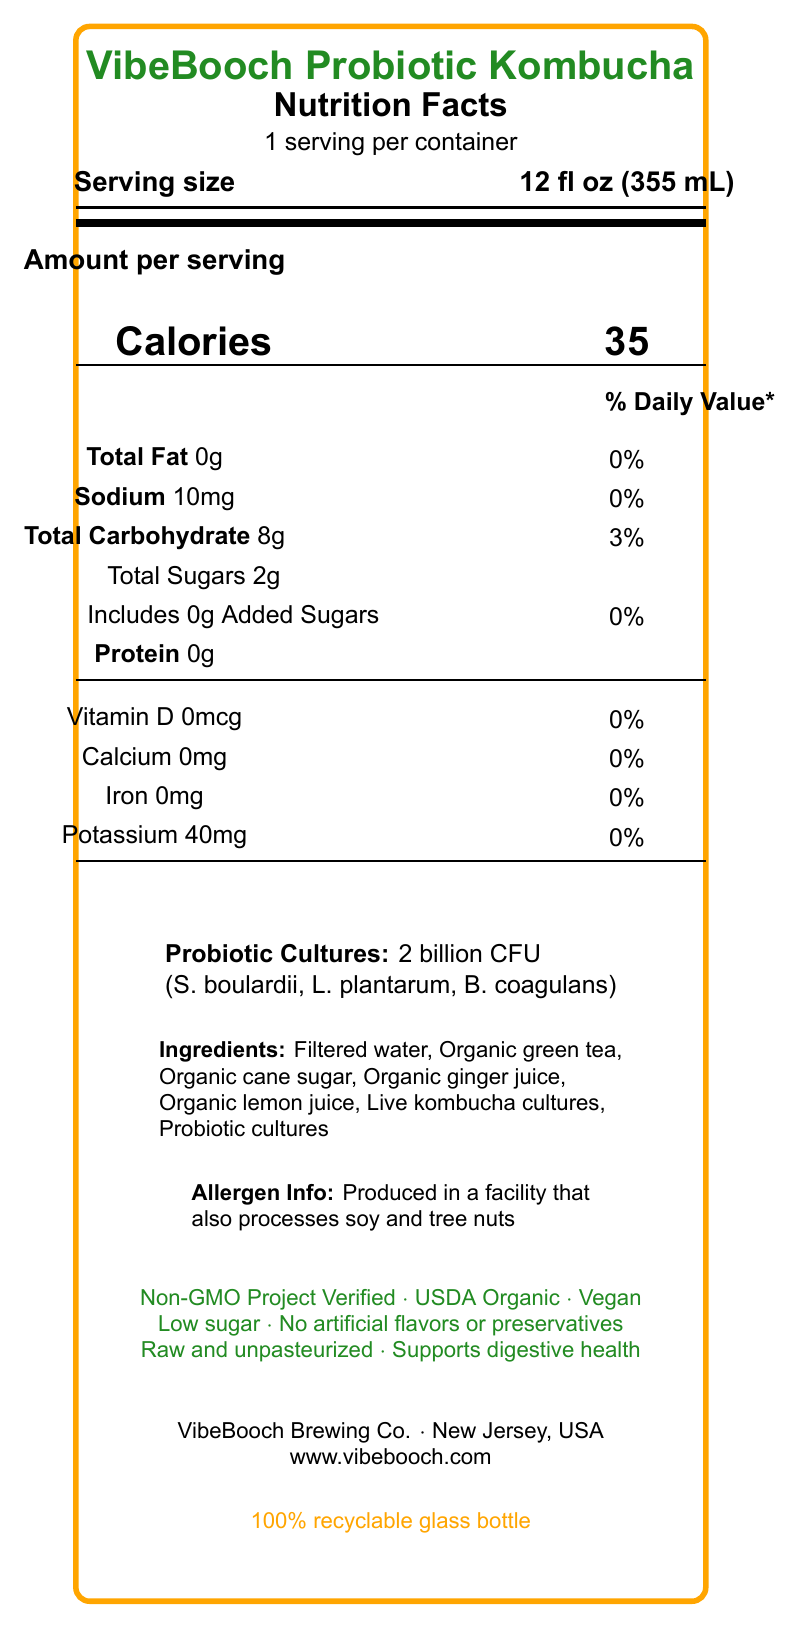what is the serving size of VibeBooch Probiotic Kombucha? The serving size is stated next to the label "Serving size" on the Nutrition Facts label.
Answer: 12 fl oz (355 mL) how many calories are in one serving of VibeBooch Probiotic Kombucha? The calorie content per serving is prominently displayed as "Calories 35" under the "Amount per serving" section.
Answer: 35 What is the total sugar content per serving? The total sugar content is listed under the "Total Sugars" section of the Nutrition Facts label.
Answer: 2g What is the amount of probiotic cultures in VibeBooch Probiotic Kombucha? The amount of probiotic cultures is listed under "Probiotic Cultures" with the details "2 billion CFU".
Answer: 2 billion CFU List the probiotic strains included in VibeBooch Probiotic Kombucha. The specific strains of probiotic cultures are listed in parentheses after "Probiotic Cultures".
Answer: Saccharomyces boulardii, Lactobacillus plantarum, Bacillus coagulans does VibeBooch Probiotic Kombucha contain added sugars? The label indicates "Includes 0g Added Sugars," meaning there are no added sugars in the drink.
Answer: No how much sodium is in one serving of VibeBooch Probiotic Kombucha? The sodium content is listed under "Sodium" in the Nutrition Facts label.
Answer: 10mg By how much can one serving of VibeBooch Probiotic Kombucha contribute to your daily carbohydrate intake? The % Daily Value for total carbohydrates in one serving is indicated as 3%.
Answer: 3% What certifications does VibeBooch hold? The certifications are listed towards the bottom of the document under the "Non-GMO Project Verified," "USDA Organic," and "Vegan" labels.
Answer: Non-GMO Project Verified, USDA Organic, Vegan In which type of packaging is VibeBooch Probiotic Kombucha sold? This information is listed at the bottom of the label, mentioning "100% recyclable glass bottle".
Answer: 100% recyclable glass bottle Does VibeBooch Probiotic Kombucha contain any artificial flavors or preservatives? One of the additional claims explicitly states "No artificial flavors or preservatives".
Answer: No Where is VibeBooch Probiotic Kombucha manufactured? The location of the manufacturer is listed towards the bottom of the label.
Answer: New Jersey, USA Which of the following is not an ingredient in VibeBooch Probiotic Kombucha? A. Organic green tea B. Organic ginger juice C. Organic lemon juice D. Organic honey The ingredient list does not include "Organic honey".
Answer: D How much protein does one serving of VibeBooch Probiotic Kombucha contain? A. 1g B. 5g C. 0g D. 3g The protein content is stated as 0g in the Nutrition Facts label.
Answer: C How much Vitamin D is in one serving? A. 0mcg B. 1mcg C. 5mcg D. 10mcg The amount of Vitamin D is listed as 0mcg in the Nutrition Facts label.
Answer: A Has VibeBooch Probiotic Kombucha been pasteurized? One of the additional claims states that the product is "Raw and unpasteurized".
Answer: No Summarize the main idea of the VibeBooch Probiotic Kombucha label. This summary captures the key points of the product including its nutritional value, probiotic content, certifications, production location, and eco-friendliness.
Answer: VibeBooch Probiotic Kombucha is a low-calorie, low-sugar drink with various probiotics and no artificial ingredients, certified vegan and organic, produced in New Jersey, USA, and packaged in a recyclable glass bottle. What is the exact production date for the VibeBooch Probiotic Kombucha? The Nutrition Facts label does not provide any information about the production date.
Answer: Not enough information Identify one major claim about the health benefits of VibeBooch Probiotic Kombucha. One of the additional claims explicitly states "Supports digestive health".
Answer: Supports digestive health 